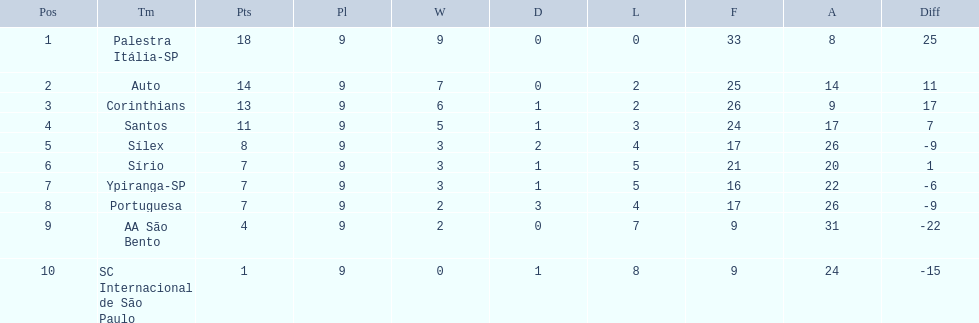How many games did each team play? 9, 9, 9, 9, 9, 9, 9, 9, 9, 9. Did any team score 13 points in the total games they played? 13. What is the name of that team? Corinthians. 